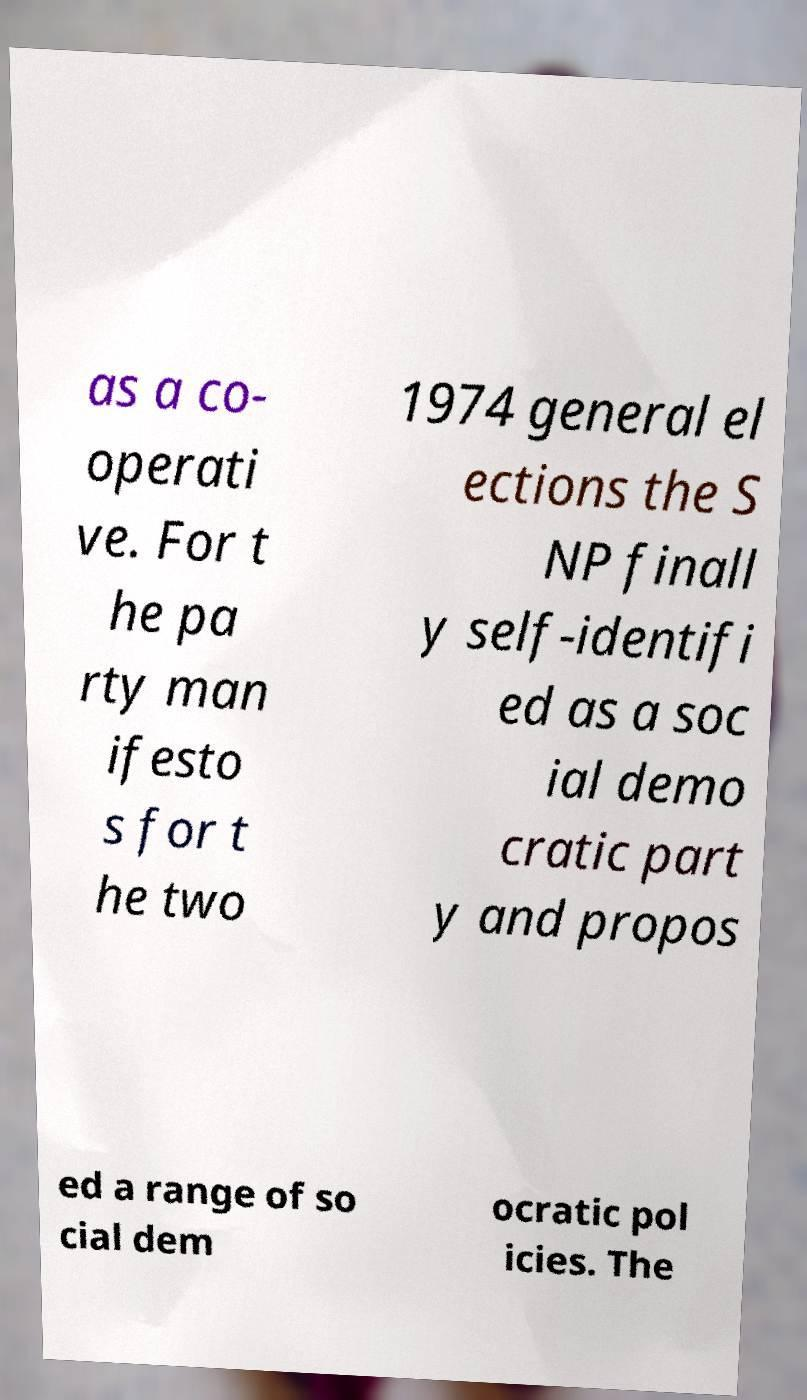For documentation purposes, I need the text within this image transcribed. Could you provide that? as a co- operati ve. For t he pa rty man ifesto s for t he two 1974 general el ections the S NP finall y self-identifi ed as a soc ial demo cratic part y and propos ed a range of so cial dem ocratic pol icies. The 